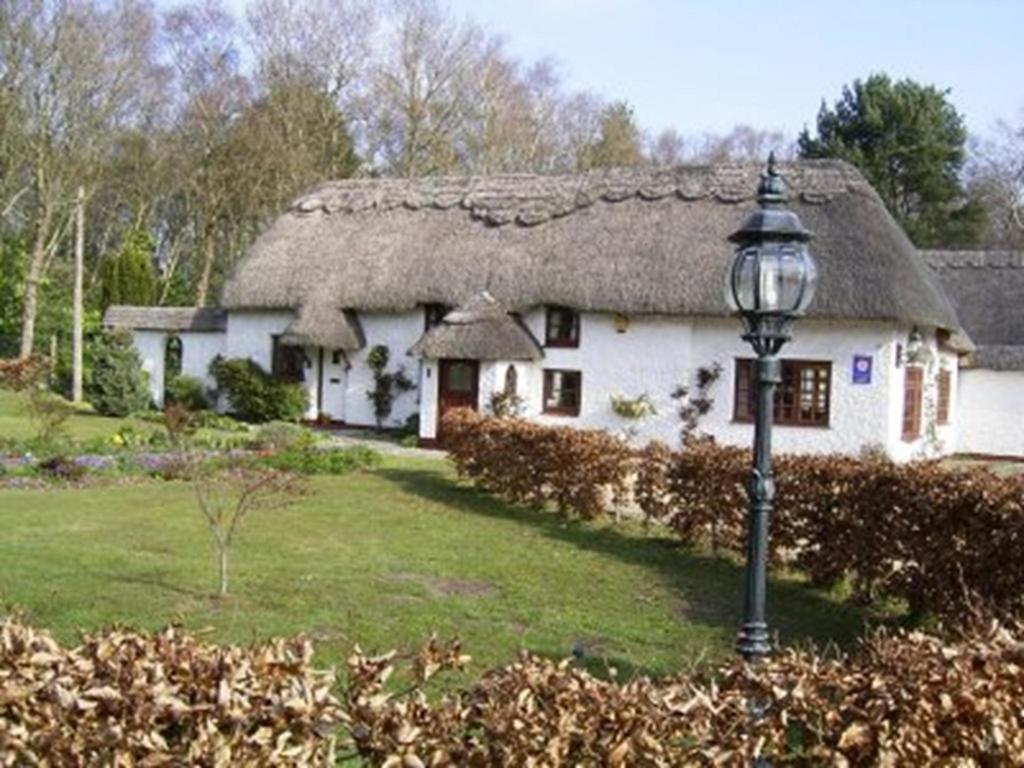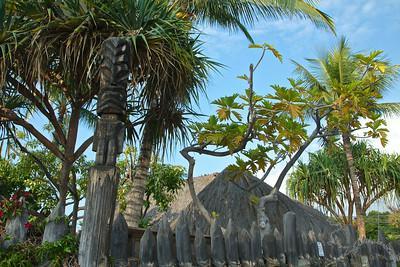The first image is the image on the left, the second image is the image on the right. Assess this claim about the two images: "One image shows a thatched umbrella shape over a seating area with a round table.". Correct or not? Answer yes or no. No. The first image is the image on the left, the second image is the image on the right. Analyze the images presented: Is the assertion "In the left image a table is covered by a roof." valid? Answer yes or no. No. 